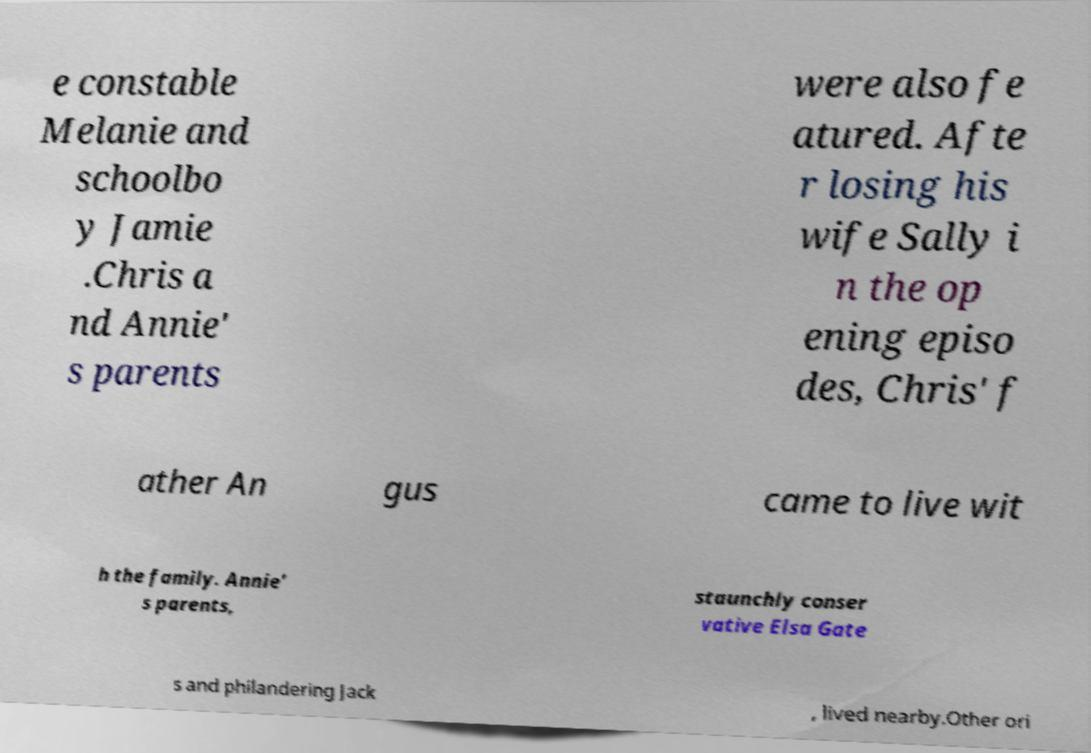Can you read and provide the text displayed in the image?This photo seems to have some interesting text. Can you extract and type it out for me? e constable Melanie and schoolbo y Jamie .Chris a nd Annie' s parents were also fe atured. Afte r losing his wife Sally i n the op ening episo des, Chris' f ather An gus came to live wit h the family. Annie' s parents, staunchly conser vative Elsa Gate s and philandering Jack , lived nearby.Other ori 